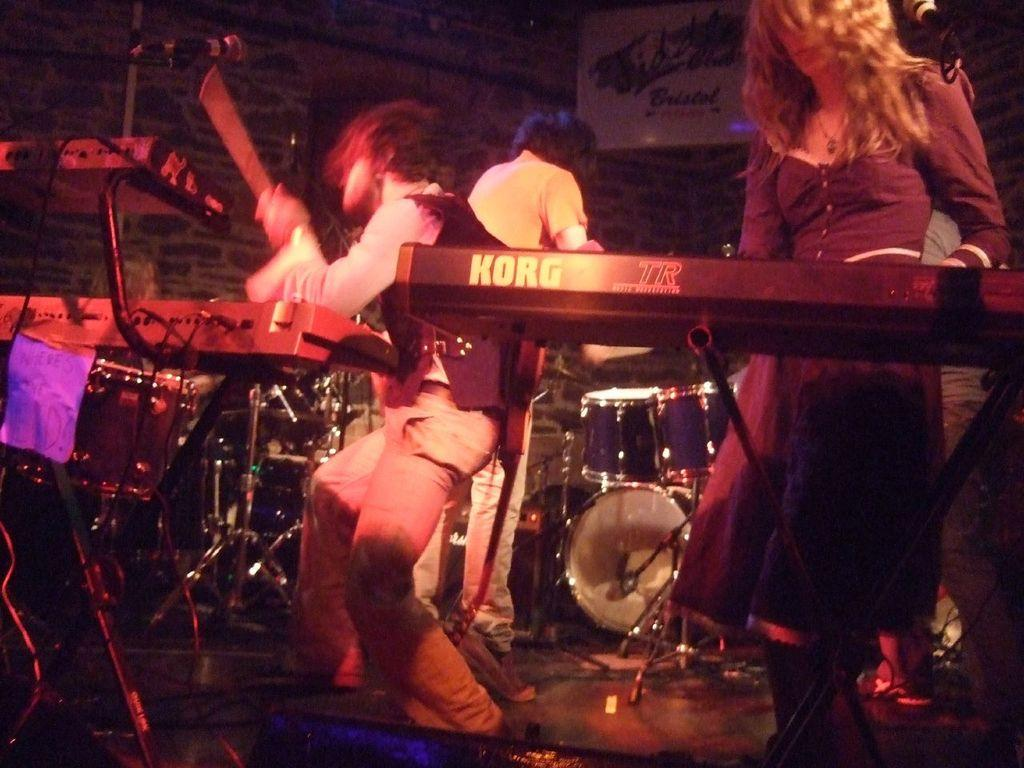What are the people in the image doing? The people in the image are playing musical instruments. What can be seen in the background of the image? There is a wall in the background of the image. What type of land can be seen in the image? There is no specific type of land visible in the image; it only shows people playing musical instruments and a wall in the background. What question is being asked by the people in the image? There is no indication in the image that a question is being asked; it only shows people playing musical instruments. 